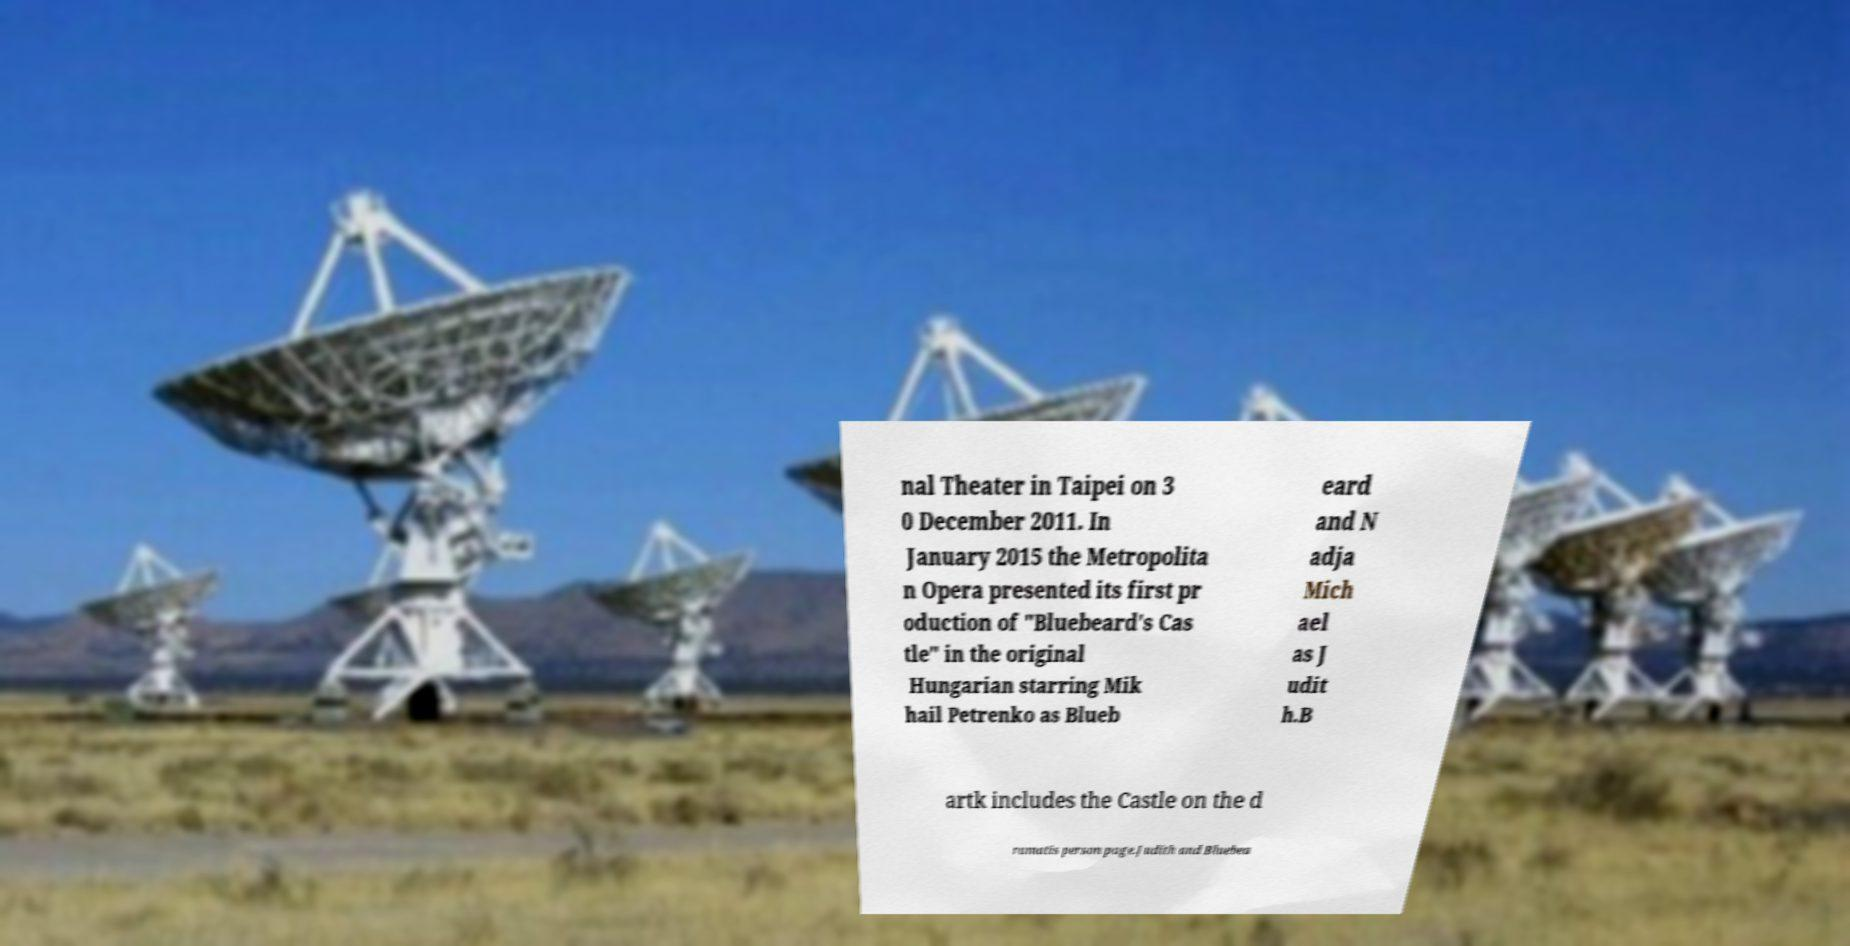There's text embedded in this image that I need extracted. Can you transcribe it verbatim? nal Theater in Taipei on 3 0 December 2011. In January 2015 the Metropolita n Opera presented its first pr oduction of "Bluebeard's Cas tle" in the original Hungarian starring Mik hail Petrenko as Blueb eard and N adja Mich ael as J udit h.B artk includes the Castle on the d ramatis person page.Judith and Bluebea 